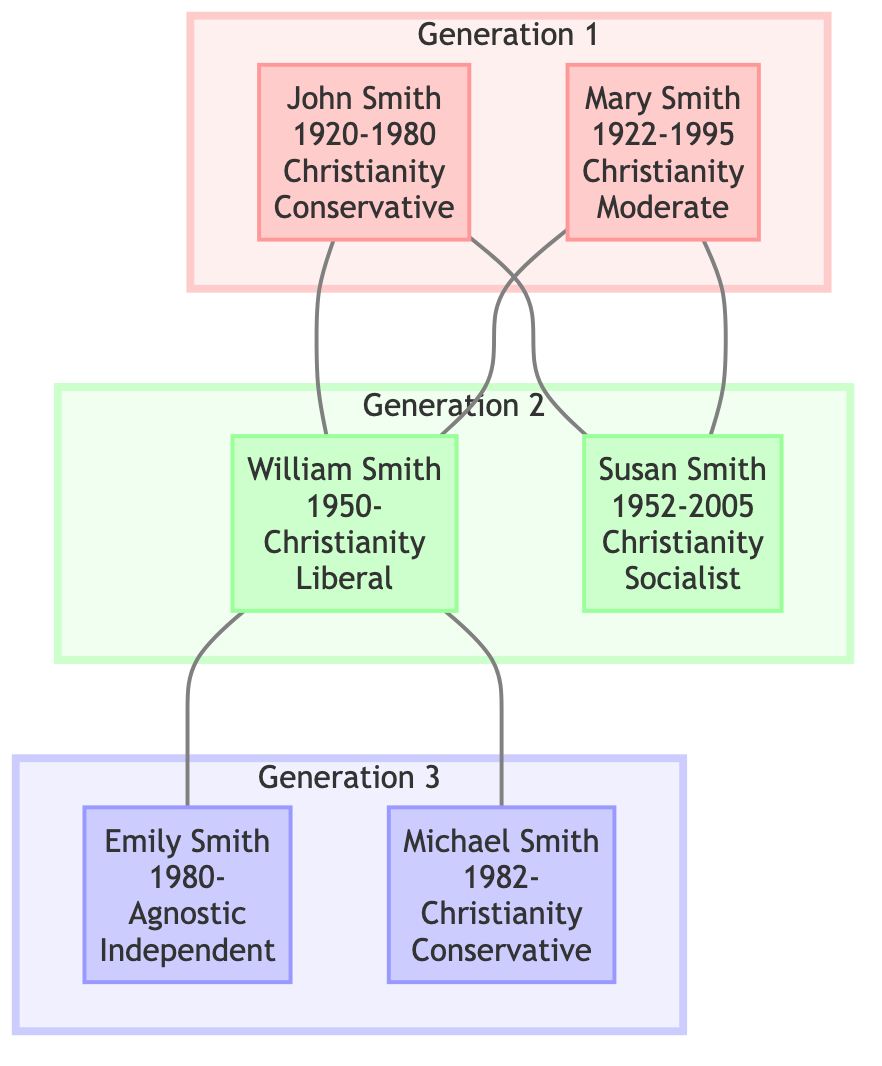What is the birth year of John Smith? The diagram lists John Smith's birth year as 1920, which is present in the node detailing his information.
Answer: 1920 How many generations are represented in the family tree? There are three generations shown in the diagram, with distinct subgraphs for each generation.
Answer: 3 Which member of the second generation has a political ideology of Liberal? William Smith is marked with the political ideology of Liberal within the second generation section of the diagram.
Answer: William Smith Name the religious belief of Emily Smith. Emily Smith's religious belief is specified as Agnostic in her node within the third generation.
Answer: Agnostic What year did Susan Smith pass away? According to the diagram, Susan Smith died in the year 2005, as stated in her node.
Answer: 2005 Which generation does Michael Smith belong to? Michael Smith is part of the third generation, as indicated in the subgraph where he is located.
Answer: Generation 3 What political event did John Smith participate in? John Smith is associated with the political event of voting for the Republican Party, noted in his set of important events.
Answer: Voted for Republican Party Which member has the most liberal political ideology across all generations? Susan Smith, in the second generation, has the most liberal ideology listed, being labeled as Socialist, followed by William Smith as Liberal.
Answer: Susan Smith Is there any member with an Independent political ideology? Yes, Emily Smith demonstrates an Independent political ideology as seen in her characteristics under the third generation.
Answer: Yes 